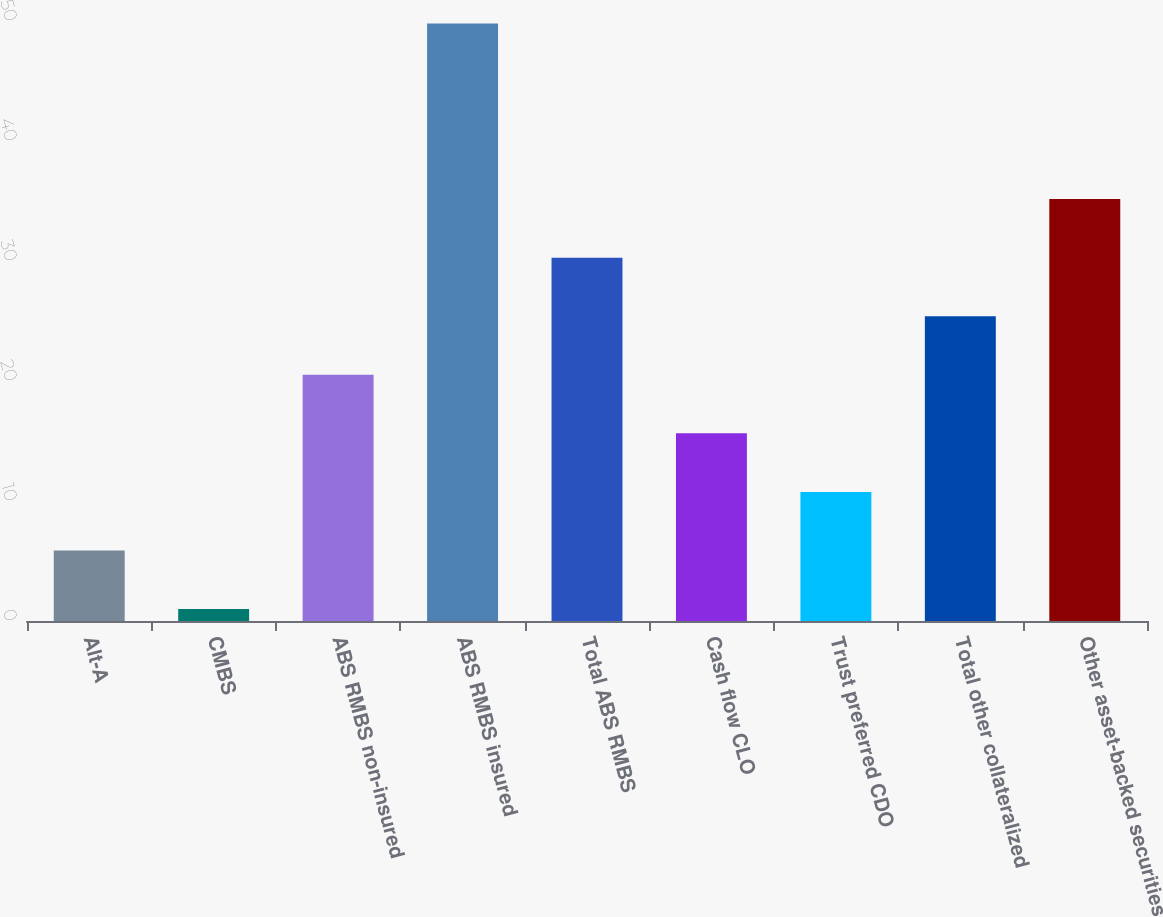Convert chart. <chart><loc_0><loc_0><loc_500><loc_500><bar_chart><fcel>Alt-A<fcel>CMBS<fcel>ABS RMBS non-insured<fcel>ABS RMBS insured<fcel>Total ABS RMBS<fcel>Cash flow CLO<fcel>Trust preferred CDO<fcel>Total other collateralized<fcel>Other asset-backed securities<nl><fcel>5.88<fcel>1<fcel>20.52<fcel>49.8<fcel>30.28<fcel>15.64<fcel>10.76<fcel>25.4<fcel>35.16<nl></chart> 